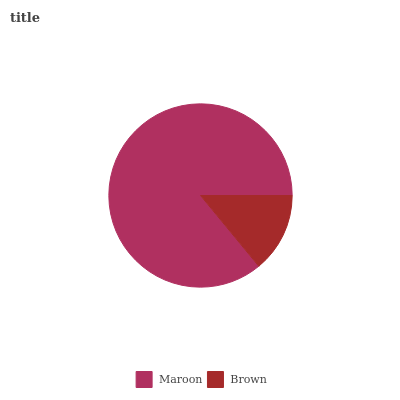Is Brown the minimum?
Answer yes or no. Yes. Is Maroon the maximum?
Answer yes or no. Yes. Is Brown the maximum?
Answer yes or no. No. Is Maroon greater than Brown?
Answer yes or no. Yes. Is Brown less than Maroon?
Answer yes or no. Yes. Is Brown greater than Maroon?
Answer yes or no. No. Is Maroon less than Brown?
Answer yes or no. No. Is Maroon the high median?
Answer yes or no. Yes. Is Brown the low median?
Answer yes or no. Yes. Is Brown the high median?
Answer yes or no. No. Is Maroon the low median?
Answer yes or no. No. 